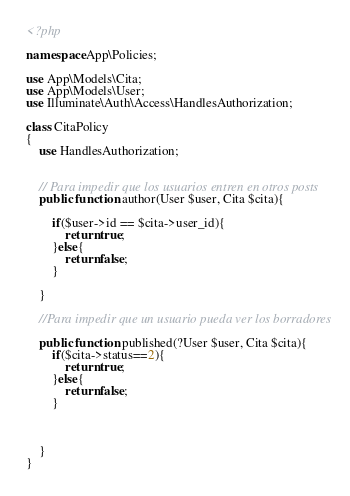<code> <loc_0><loc_0><loc_500><loc_500><_PHP_><?php

namespace App\Policies;

use App\Models\Cita;
use App\Models\User;
use Illuminate\Auth\Access\HandlesAuthorization;

class CitaPolicy
{
    use HandlesAuthorization;


    // Para impedir que los usuarios entren en otros posts
    public function author(User $user, Cita $cita){

        if($user->id == $cita->user_id){
            return true;
        }else{
            return false;
        }

    }

    //Para impedir que un usuario pueda ver los borradores

    public function published(?User $user, Cita $cita){
        if($cita->status==2){
            return true;
        }else{
            return false;
        }



    }
}
</code> 